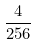<formula> <loc_0><loc_0><loc_500><loc_500>\frac { 4 } { 2 5 6 }</formula> 